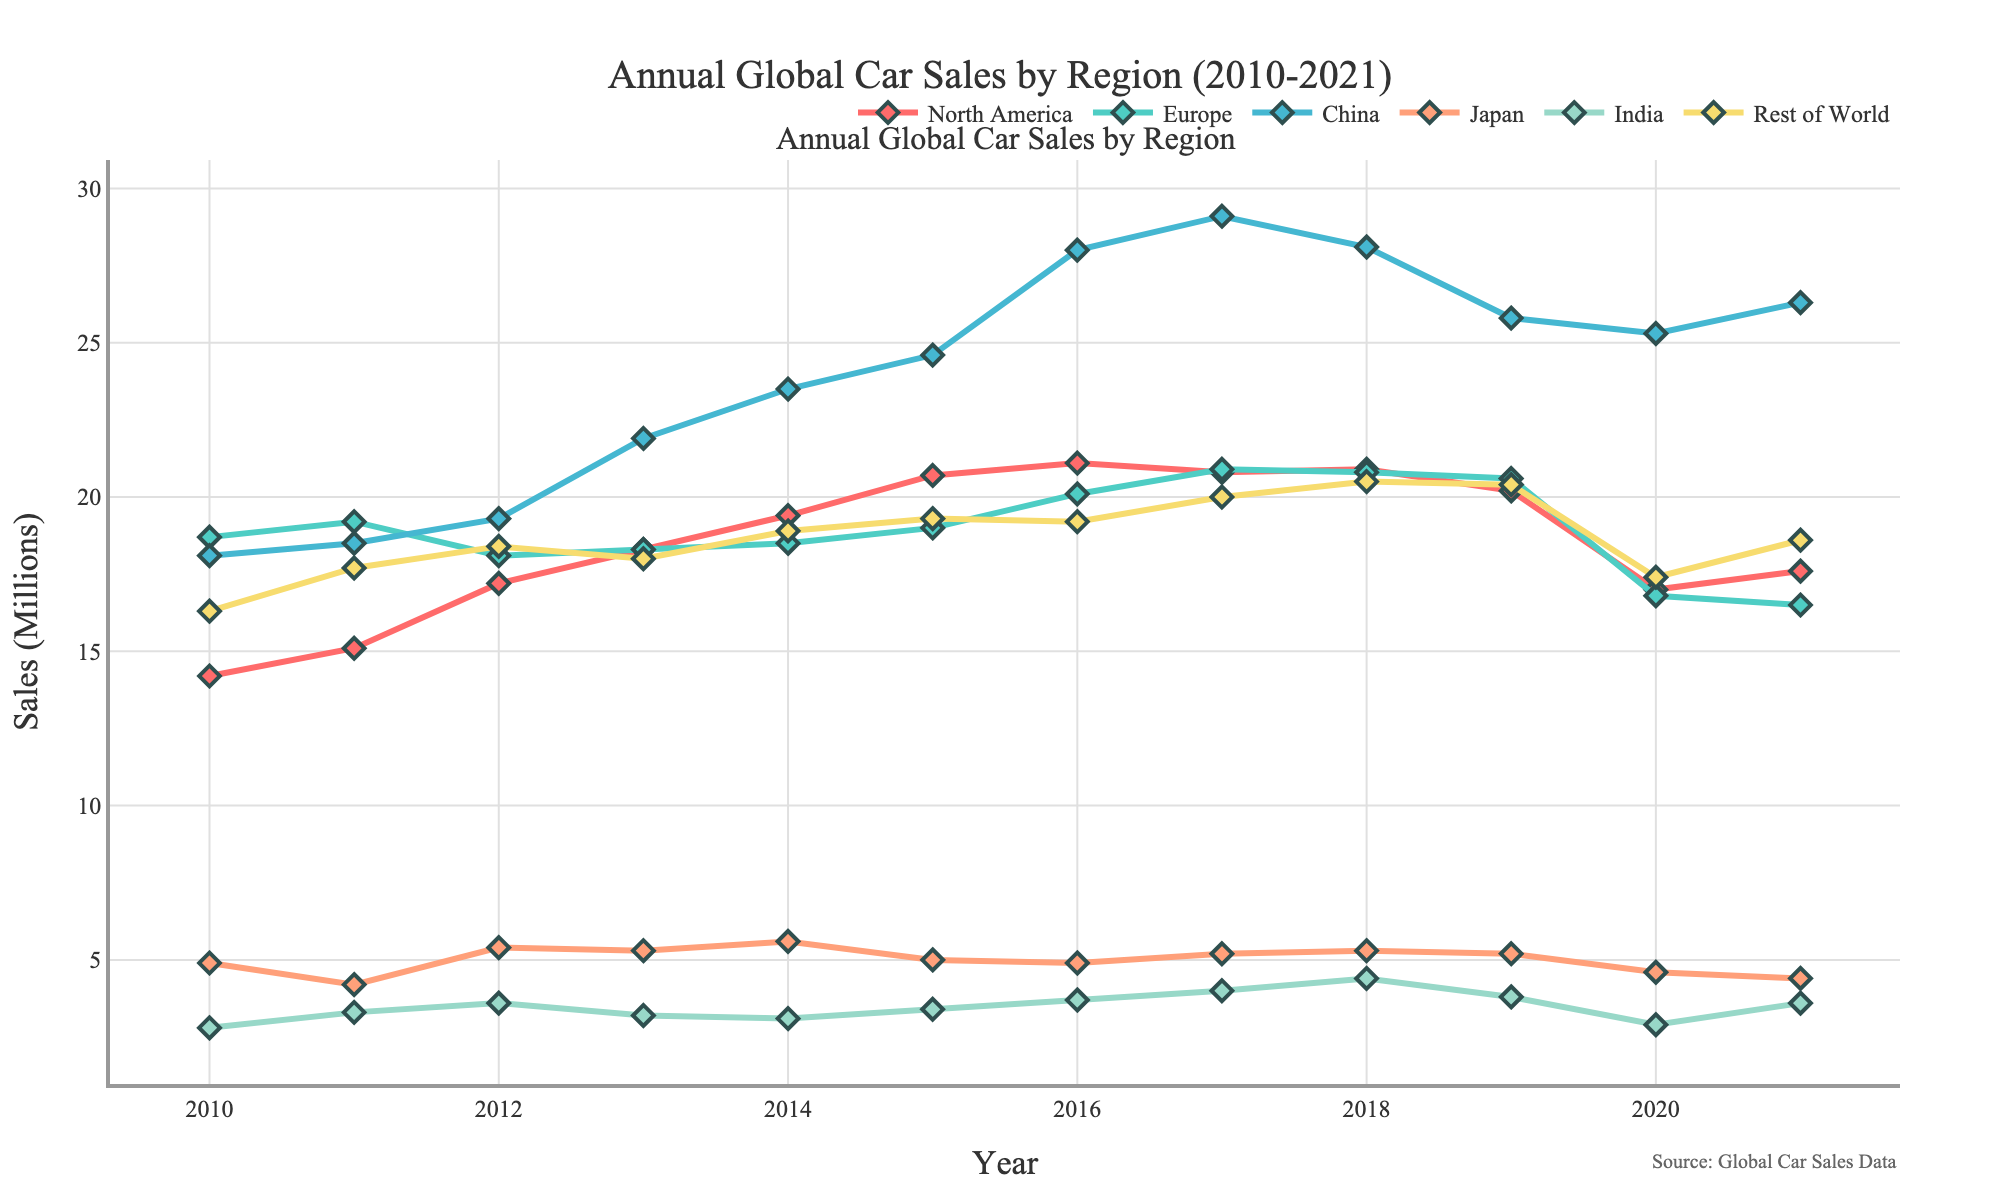Which region had the highest car sales in 2021? The chart shows data for several regions, and one of them will have the highest point in the year 2021. By observing the endpoints of the lines, China has the highest value in 2021.
Answer: China Which region experienced the largest decrease in car sales from 2019 to 2020? By looking at the drop from 2019 to 2020 for each region, North America saw the most significant decline in car sales.
Answer: North America What is the overall trend of car sales in Europe from 2010 to 2021? The line for Europe starts from 18.7 million in 2010 and ends at 16.5 million in 2021, showing a slight overall decrease with some fluctuations in-between.
Answer: Decreasing Compare the car sales trends of China and North America from 2016 to 2021. From 2016, China shows a general increasing trend, peaking in 2018 and then slightly declining but still high. North America shows fluctuations with a peak in 2016 and a notable drop in 2020, partially recovering in 2021.
Answer: China's trend is generally increasing, while North America shows fluctuations with a decline towards the end Calculate the average car sales in India across all the years. Add all the car sales values for India from 2010 to 2021 and divide by the number of years (12). (2.8 + 3.3 + 3.6 + 3.2 + 3.1 + 3.4 + 3.7 + 4.0 + 4.4 + 3.8 + 2.9 + 3.6) / 12 = 3.508 million
Answer: 3.51 million Which region had the most consistent car sales from 2010 to 2021? Consistency means the line is relatively flat with minimal fluctuations. Japan's sales show the least amount of variance over these years.
Answer: Japan How did the total car sales of North America and Europe combined change from 2010 to 2021? Sum the values for North America and Europe for both 2010 and 2021 and compare them. 2010: 14.2 + 18.7 = 32.9 million, 2021: 17.6 + 16.5 = 34.1 million, showing a slight increase.
Answer: Increased from 32.9 million to 34.1 million In which year did Europe have car sales equal to China's car sales the previous year? In 2017, Europe had car sales of 20.9 million, which equals China's car sales in 2016.
Answer: 2017 Compare the maximum car sales values for China and India within this period. China reaches a maximum value of 29.1 million in 2017, while India reaches a peak of 4.4 million in 2018.
Answer: China's peak is 29.1 million, and India's peak is 4.4 million During which year did North America have the highest car sales, and what was the value? The line for North America reaches its highest point in 2016 with a value of 21.1 million.
Answer: 2016, 21.1 million 